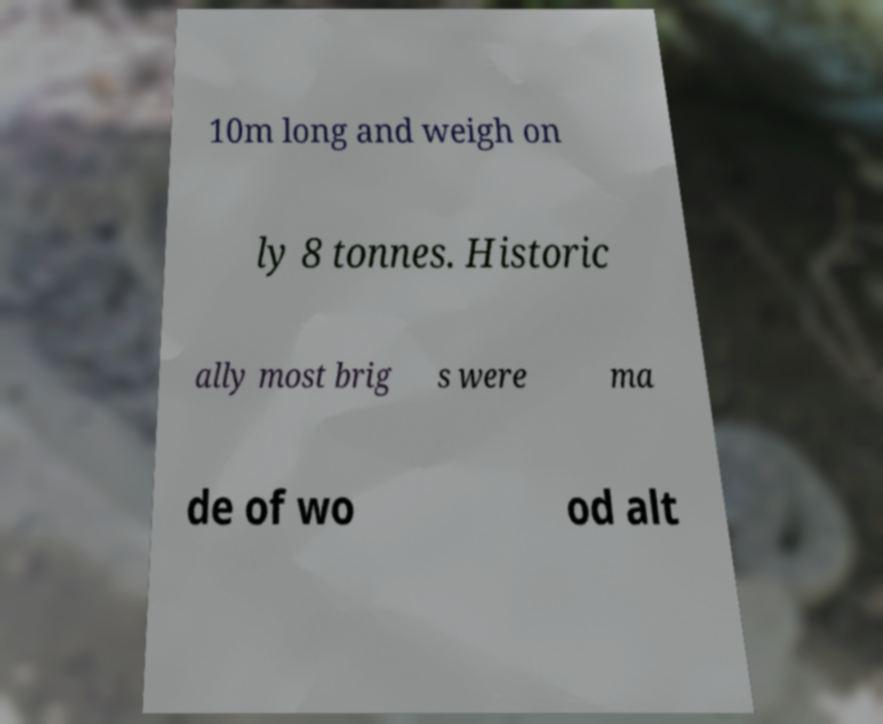Can you read and provide the text displayed in the image?This photo seems to have some interesting text. Can you extract and type it out for me? 10m long and weigh on ly 8 tonnes. Historic ally most brig s were ma de of wo od alt 